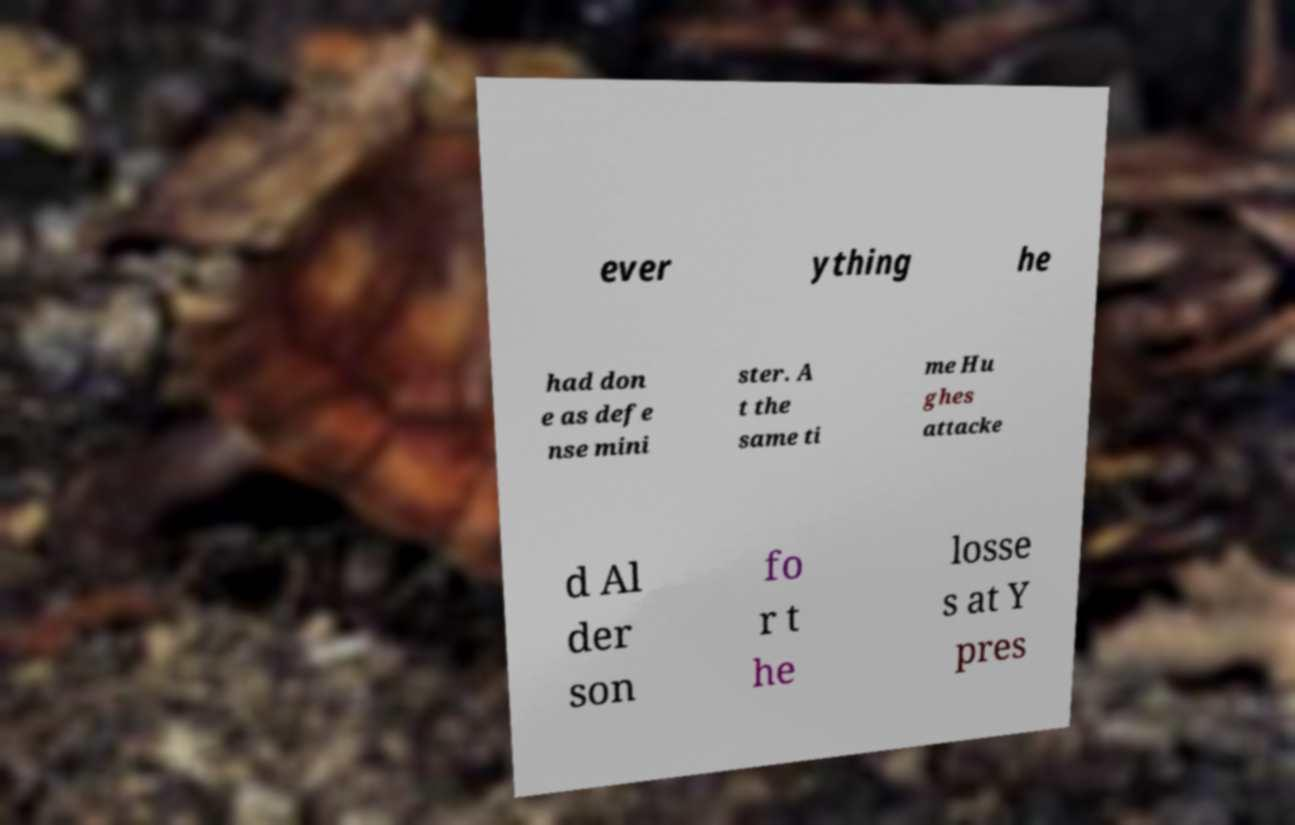Please read and relay the text visible in this image. What does it say? ever ything he had don e as defe nse mini ster. A t the same ti me Hu ghes attacke d Al der son fo r t he losse s at Y pres 